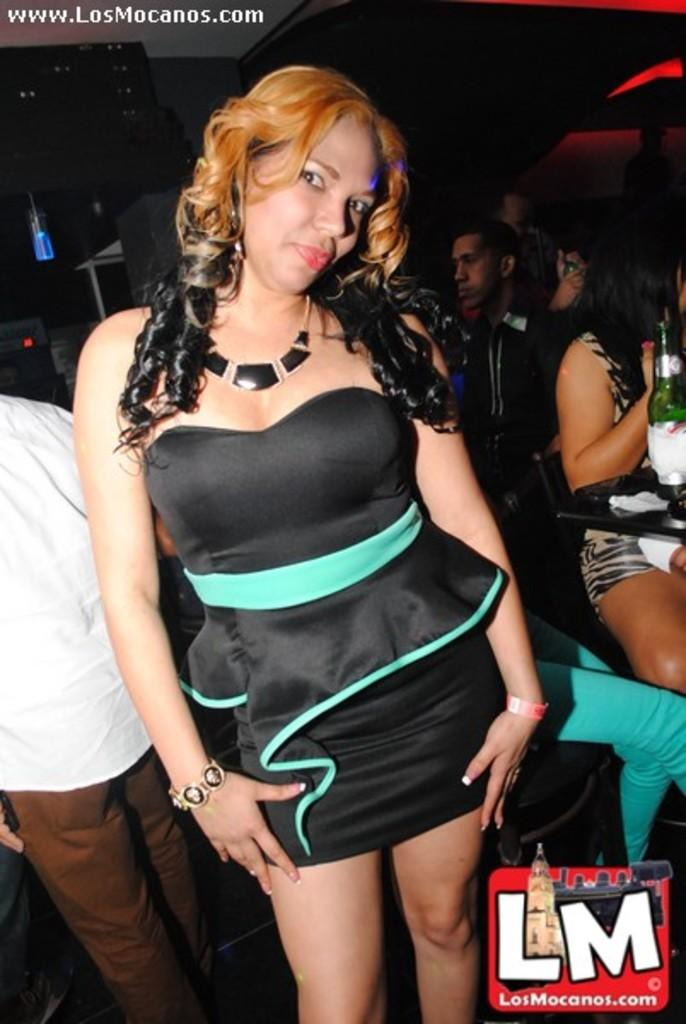What is the woman in the image doing? The woman is posing for a photograph. Can you describe the background of the image? There are people standing in the background. What is located in the bottom right of the image? There is a logo in the bottom right of the image. What is present in the top left of the image? There is text in the top left of the image. What type of vein is visible on the woman's arm in the image? There is no visible vein on the woman's arm in the image. What type of juice is being served to the people in the background? There is no juice or indication of any beverage being served in the image. 